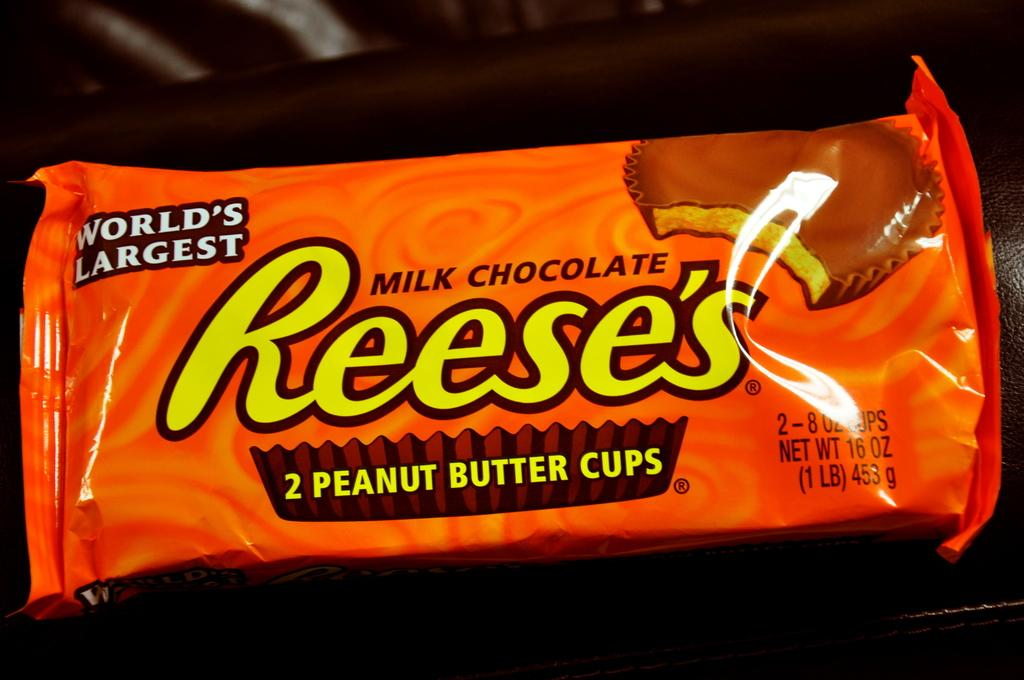Provide a one-sentence caption for the provided image. An orange Reese's milk chocolate candy bar sits on a table. 